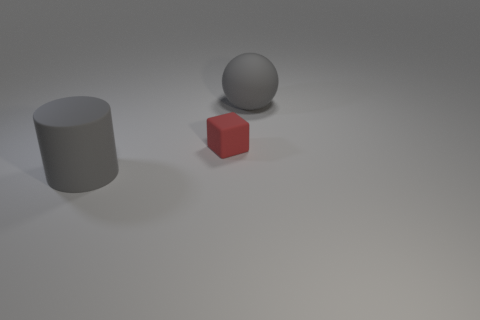What is the material of the big cylinder?
Offer a terse response. Rubber. Is the number of tiny things greater than the number of big blue metallic cubes?
Provide a short and direct response. Yes. Are there any other things that have the same shape as the small object?
Your answer should be compact. No. Is the color of the cylinder that is on the left side of the tiny rubber block the same as the large rubber thing right of the tiny red cube?
Give a very brief answer. Yes. Are there fewer things in front of the cylinder than tiny matte blocks to the left of the small thing?
Offer a terse response. No. There is a gray rubber thing behind the tiny red matte object; what is its shape?
Offer a very short reply. Sphere. There is a object that is the same color as the rubber cylinder; what is its material?
Ensure brevity in your answer.  Rubber. What number of other things are made of the same material as the cube?
Ensure brevity in your answer.  2. There is a tiny object; is its shape the same as the big object on the right side of the large gray cylinder?
Your response must be concise. No. There is a red thing that is made of the same material as the big gray ball; what is its shape?
Keep it short and to the point. Cube. 